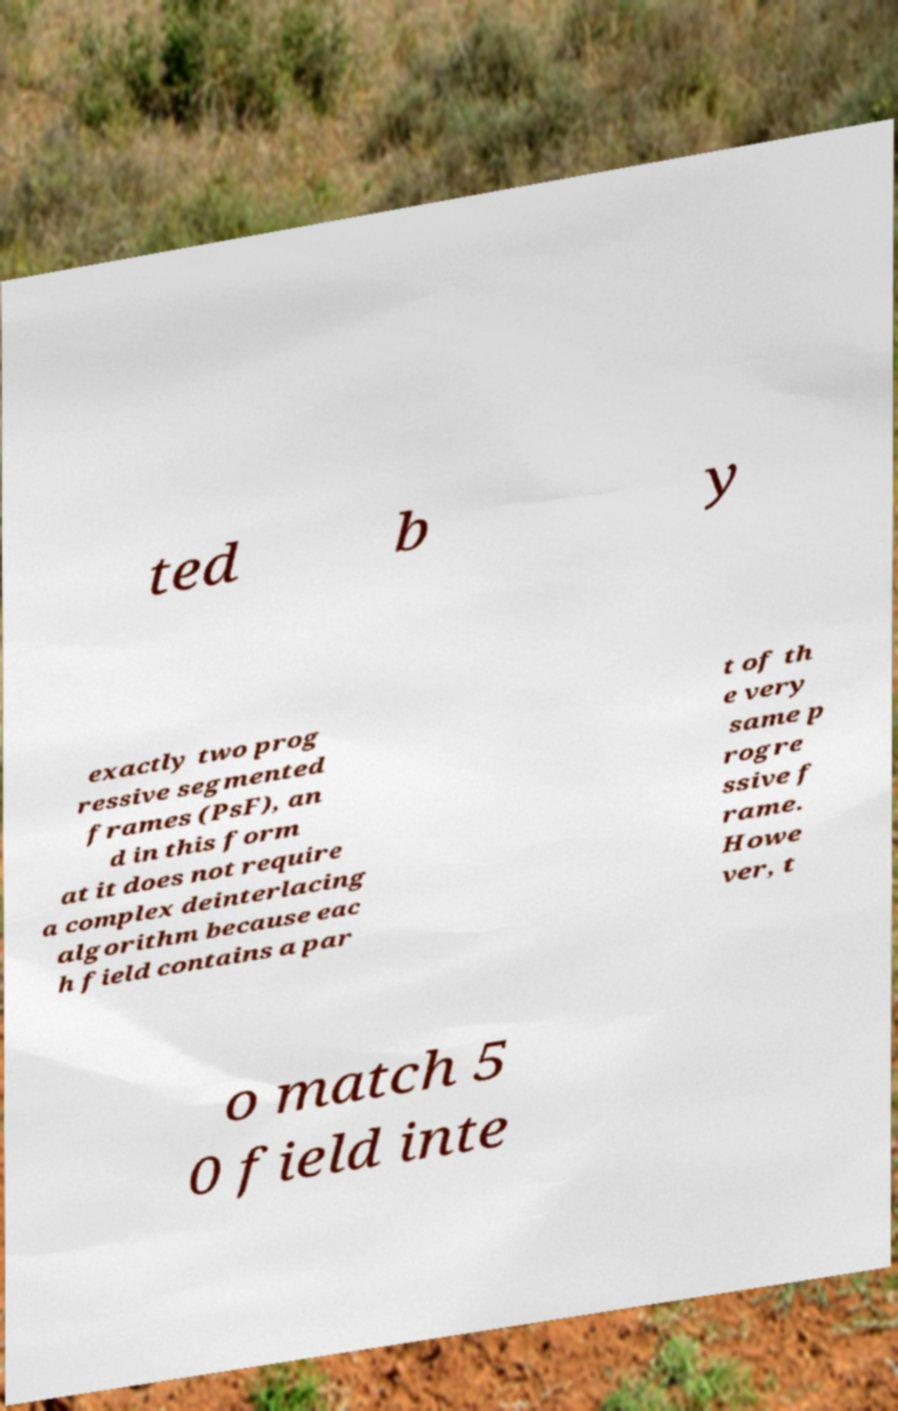Please read and relay the text visible in this image. What does it say? ted b y exactly two prog ressive segmented frames (PsF), an d in this form at it does not require a complex deinterlacing algorithm because eac h field contains a par t of th e very same p rogre ssive f rame. Howe ver, t o match 5 0 field inte 